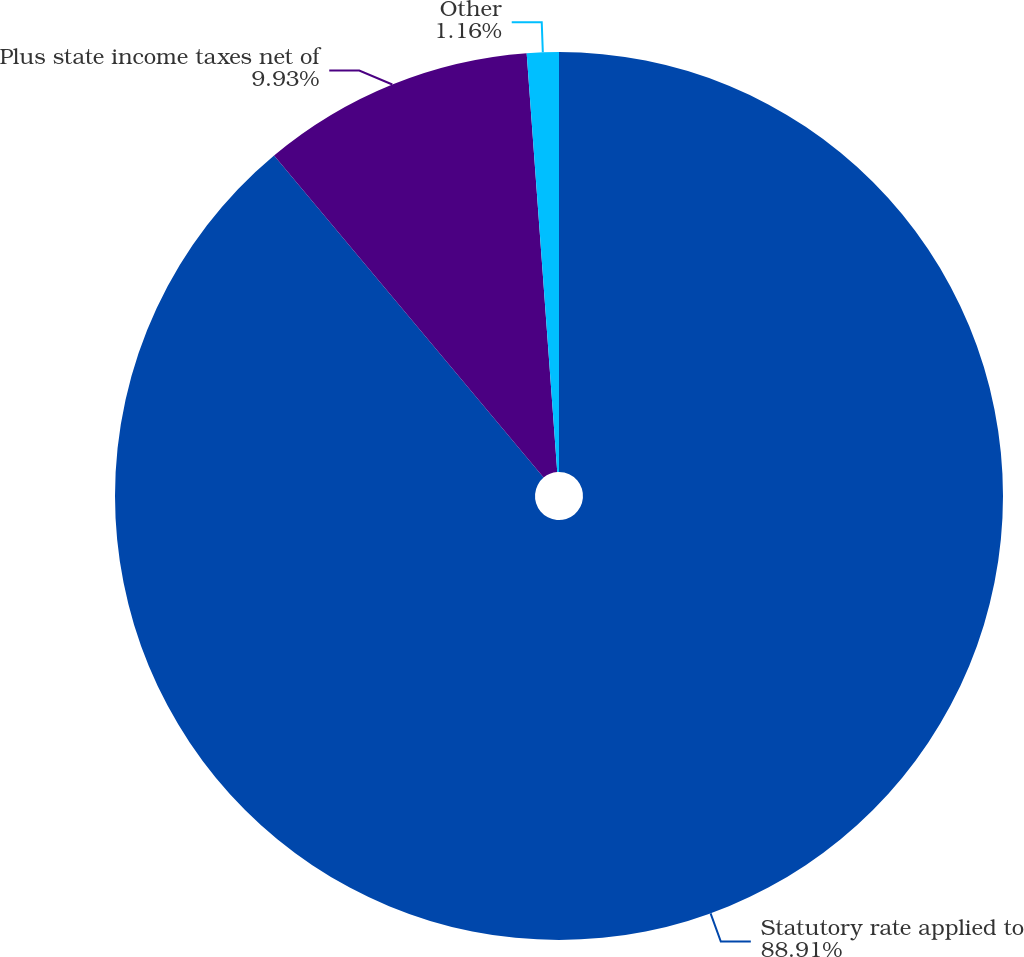<chart> <loc_0><loc_0><loc_500><loc_500><pie_chart><fcel>Statutory rate applied to<fcel>Plus state income taxes net of<fcel>Other<nl><fcel>88.91%<fcel>9.93%<fcel>1.16%<nl></chart> 